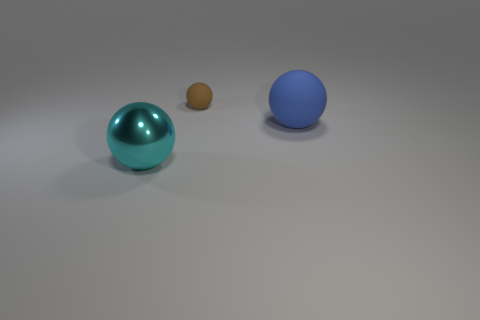Add 3 large brown matte blocks. How many objects exist? 6 Subtract all brown matte objects. Subtract all large cyan balls. How many objects are left? 1 Add 1 big blue spheres. How many big blue spheres are left? 2 Add 1 big red spheres. How many big red spheres exist? 1 Subtract 0 blue cubes. How many objects are left? 3 